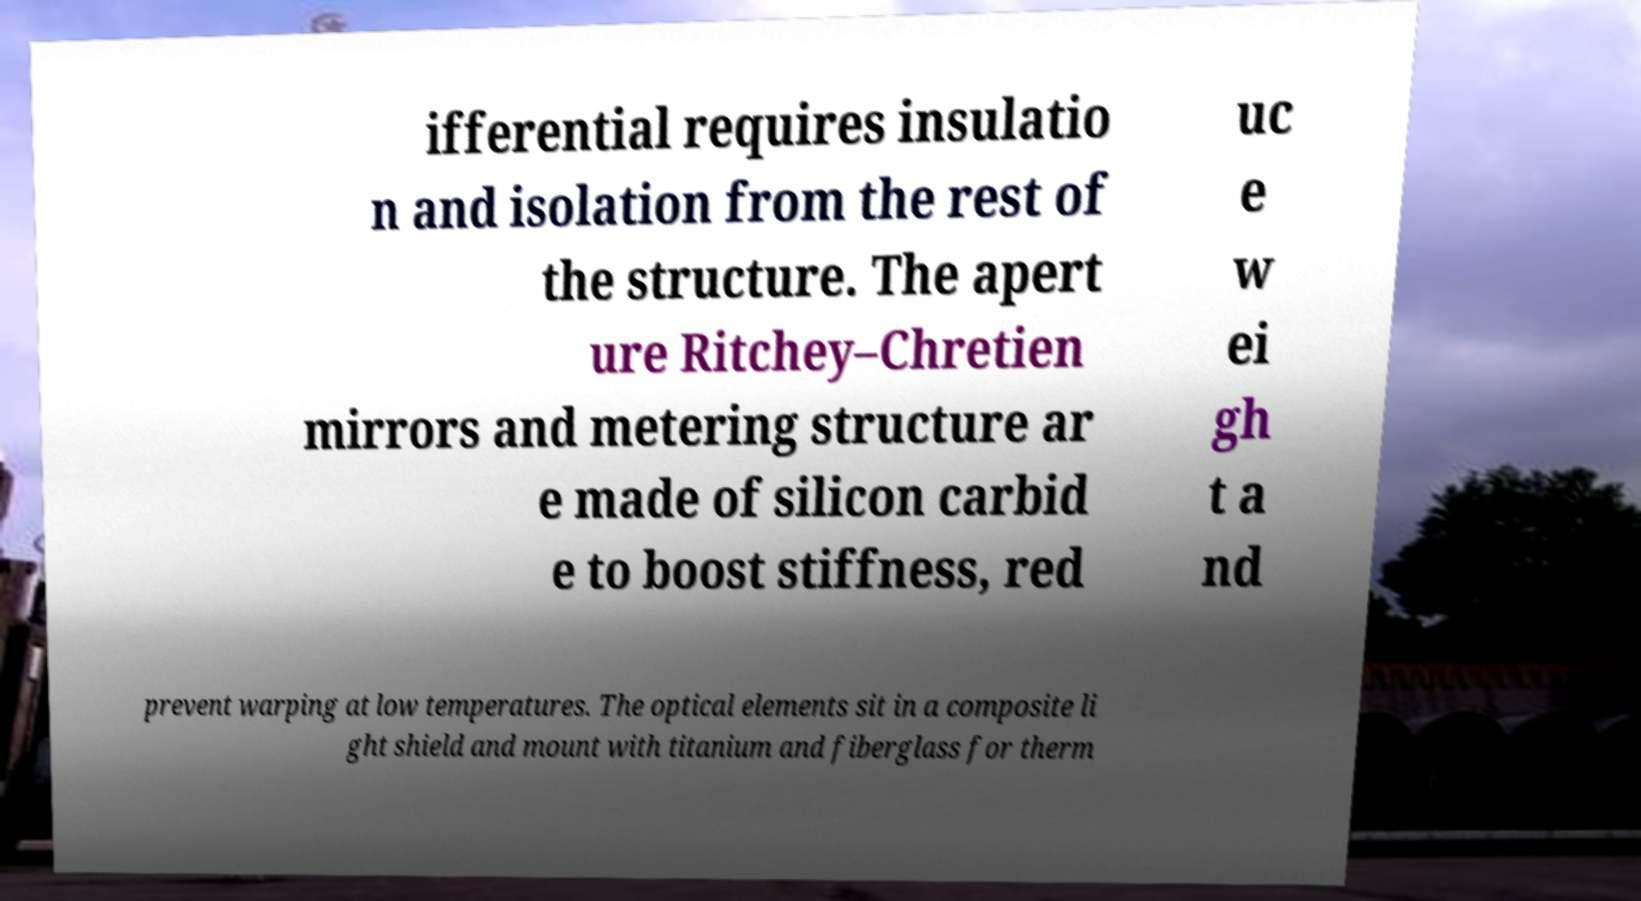For documentation purposes, I need the text within this image transcribed. Could you provide that? ifferential requires insulatio n and isolation from the rest of the structure. The apert ure Ritchey–Chretien mirrors and metering structure ar e made of silicon carbid e to boost stiffness, red uc e w ei gh t a nd prevent warping at low temperatures. The optical elements sit in a composite li ght shield and mount with titanium and fiberglass for therm 